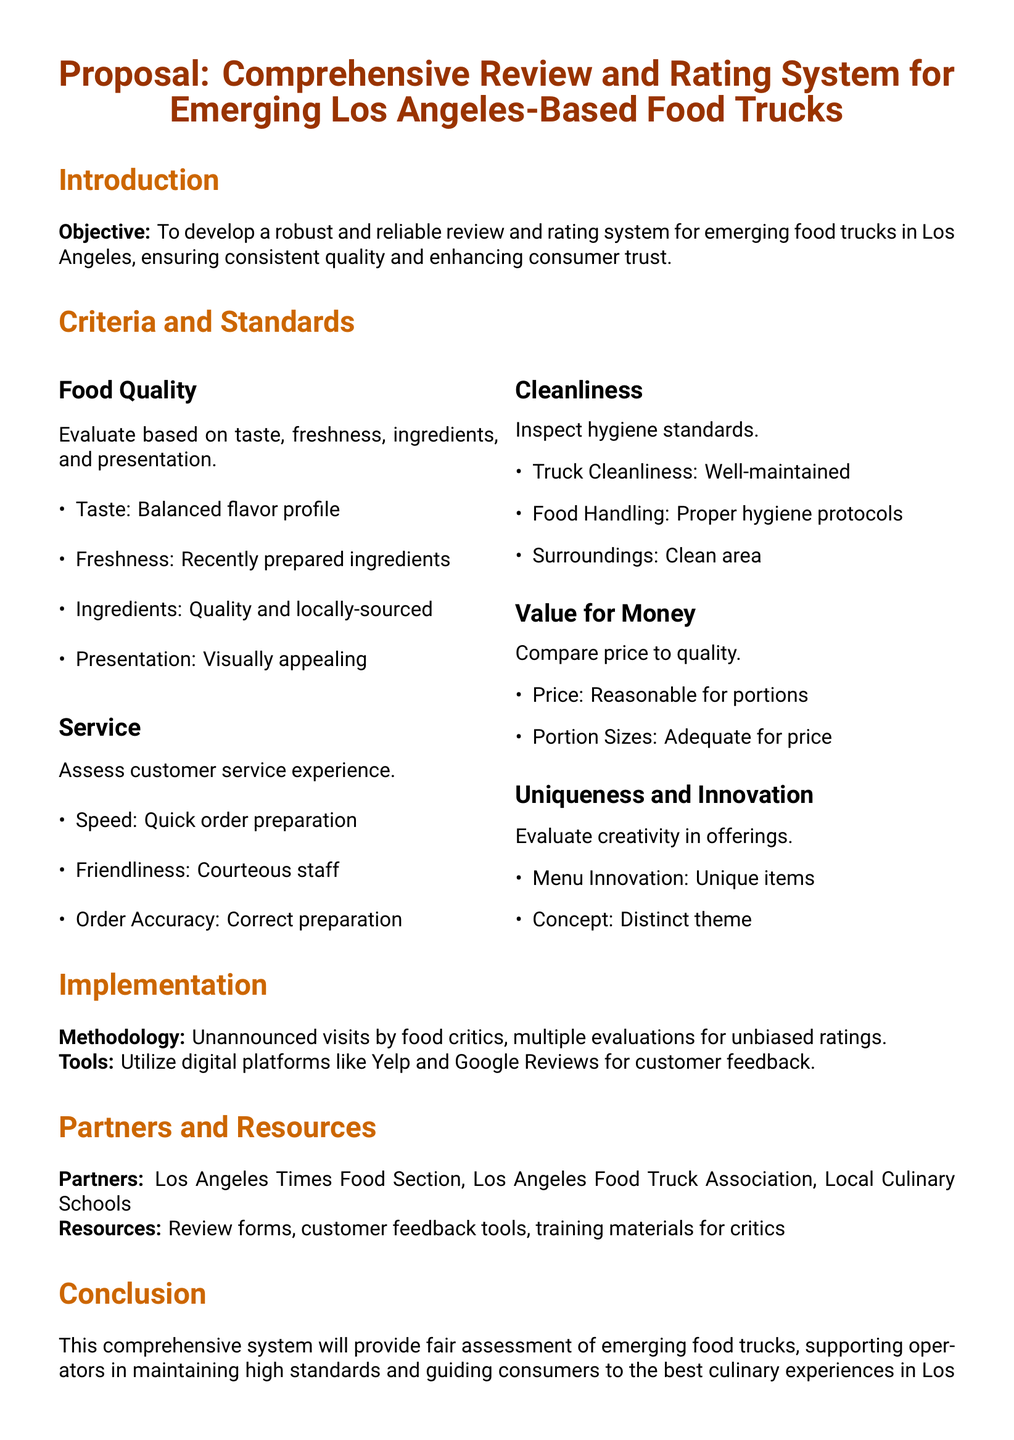What is the main objective of the proposal? The main objective is to develop a robust and reliable review and rating system for emerging food trucks in Los Angeles.
Answer: To develop a robust and reliable review and rating system for emerging food trucks in Los Angeles How many areas are evaluated under the criteria and standards section? There are five areas evaluated under the criteria and standards section: Food Quality, Service, Cleanliness, Value for Money, and Uniqueness and Innovation.
Answer: Five What does the evaluation of food quality include? The evaluation of food quality includes taste, freshness, ingredients, and presentation.
Answer: Taste, freshness, ingredients, and presentation Which item is listed under the service criteria? Under the service criteria, Speed, Friendliness, and Order Accuracy are listed.
Answer: Speed What type of visits will be conducted for evaluation? Unannounced visits by food critics will be conducted for evaluation.
Answer: Unannounced visits Name one partner mentioned in the proposal. One partner mentioned in the proposal is the Los Angeles Times Food Section.
Answer: Los Angeles Times Food Section What tools will be utilized for customer feedback? Digital platforms like Yelp and Google Reviews will be utilized for customer feedback.
Answer: Yelp and Google Reviews What aspect does 'Uniqueness and Innovation' refer to? It refers to the creativity in menu offerings and the distinctness of the food truck concept.
Answer: Creativity in offerings What is the conclusion regarding the proposed system? The conclusion states that the system will provide a fair assessment of emerging food trucks.
Answer: Fair assessment of emerging food trucks 